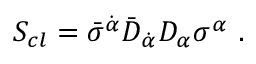Convert formula to latex. <formula><loc_0><loc_0><loc_500><loc_500>S _ { c l } = \bar { \sigma } ^ { \dot { \alpha } } \bar { D } _ { \dot { \alpha } } D _ { \alpha } \sigma ^ { \alpha } \ .</formula> 